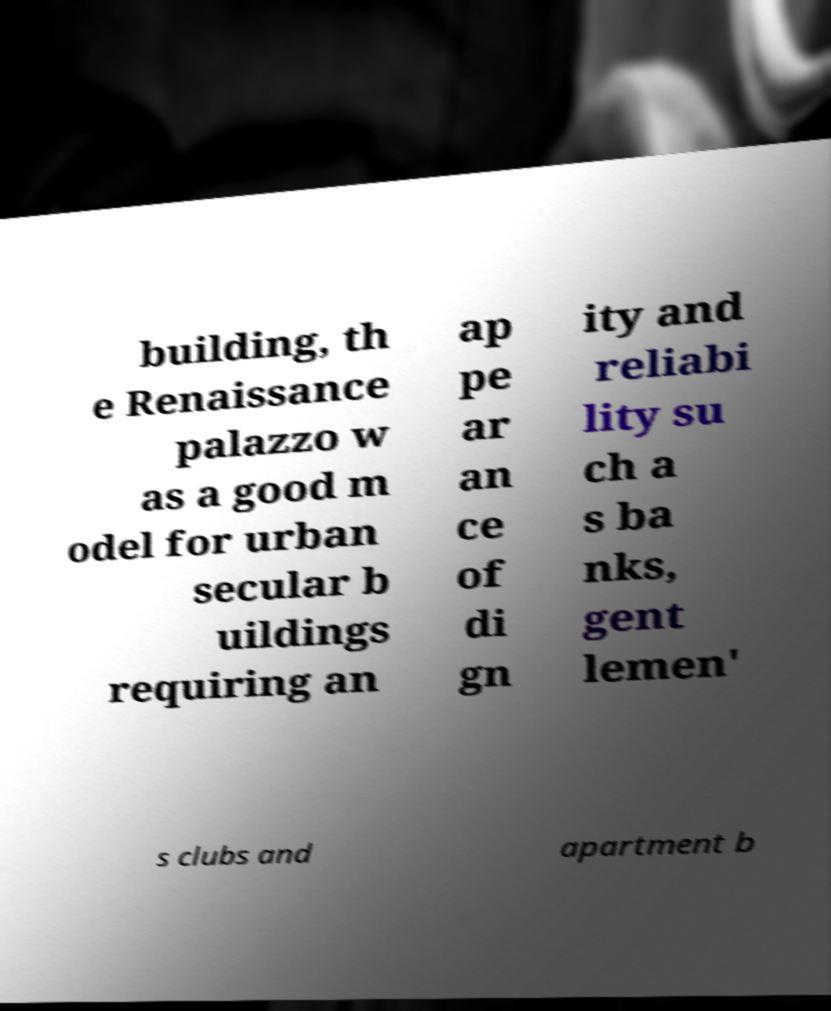Please identify and transcribe the text found in this image. building, th e Renaissance palazzo w as a good m odel for urban secular b uildings requiring an ap pe ar an ce of di gn ity and reliabi lity su ch a s ba nks, gent lemen' s clubs and apartment b 